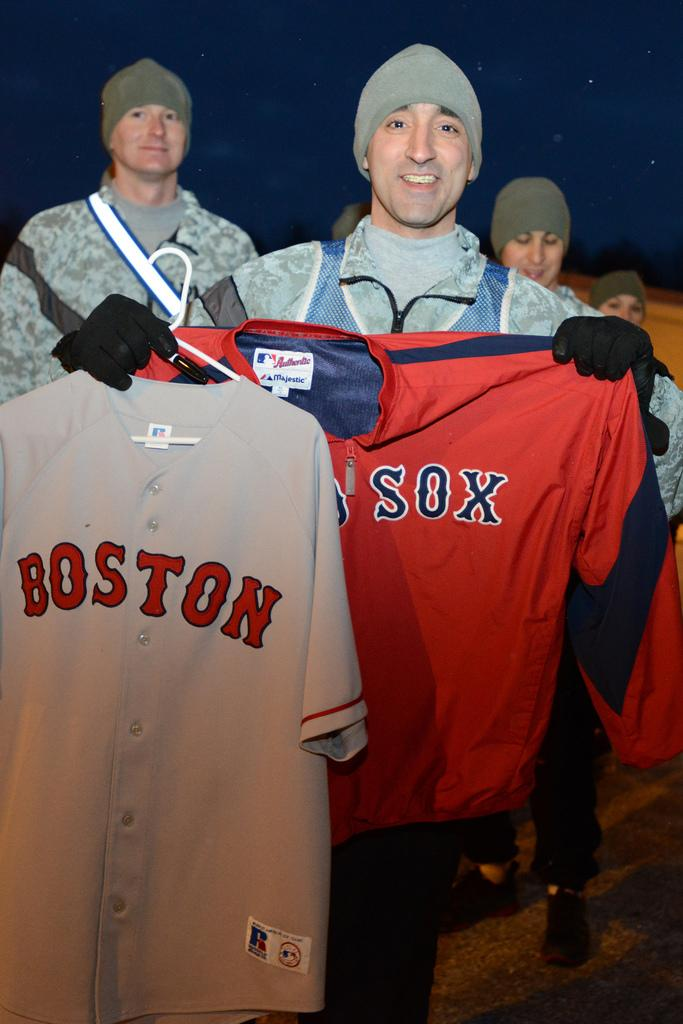<image>
Summarize the visual content of the image. a man holding onto a Red Sox jersey 